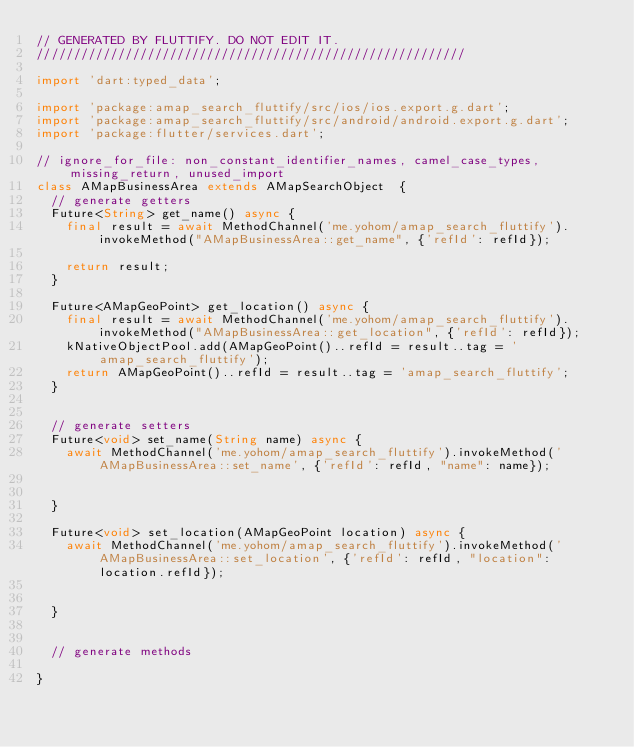Convert code to text. <code><loc_0><loc_0><loc_500><loc_500><_Dart_>// GENERATED BY FLUTTIFY. DO NOT EDIT IT.
//////////////////////////////////////////////////////////

import 'dart:typed_data';

import 'package:amap_search_fluttify/src/ios/ios.export.g.dart';
import 'package:amap_search_fluttify/src/android/android.export.g.dart';
import 'package:flutter/services.dart';

// ignore_for_file: non_constant_identifier_names, camel_case_types, missing_return, unused_import
class AMapBusinessArea extends AMapSearchObject  {
  // generate getters
  Future<String> get_name() async {
    final result = await MethodChannel('me.yohom/amap_search_fluttify').invokeMethod("AMapBusinessArea::get_name", {'refId': refId});
  
    return result;
  }
  
  Future<AMapGeoPoint> get_location() async {
    final result = await MethodChannel('me.yohom/amap_search_fluttify').invokeMethod("AMapBusinessArea::get_location", {'refId': refId});
    kNativeObjectPool.add(AMapGeoPoint()..refId = result..tag = 'amap_search_fluttify');
    return AMapGeoPoint()..refId = result..tag = 'amap_search_fluttify';
  }
  

  // generate setters
  Future<void> set_name(String name) async {
    await MethodChannel('me.yohom/amap_search_fluttify').invokeMethod('AMapBusinessArea::set_name', {'refId': refId, "name": name});
  
  
  }
  
  Future<void> set_location(AMapGeoPoint location) async {
    await MethodChannel('me.yohom/amap_search_fluttify').invokeMethod('AMapBusinessArea::set_location', {'refId': refId, "location": location.refId});
  
  
  }
  

  // generate methods
  
}</code> 